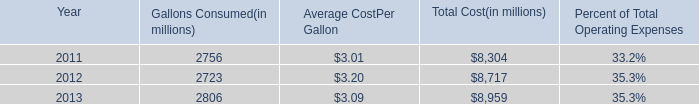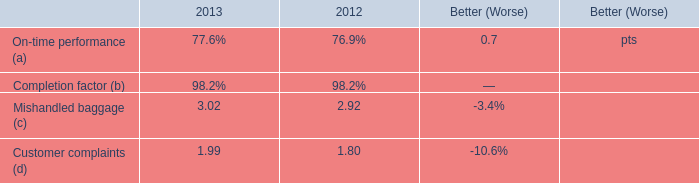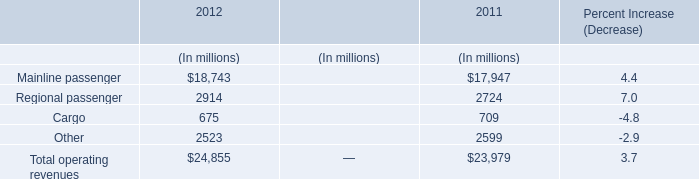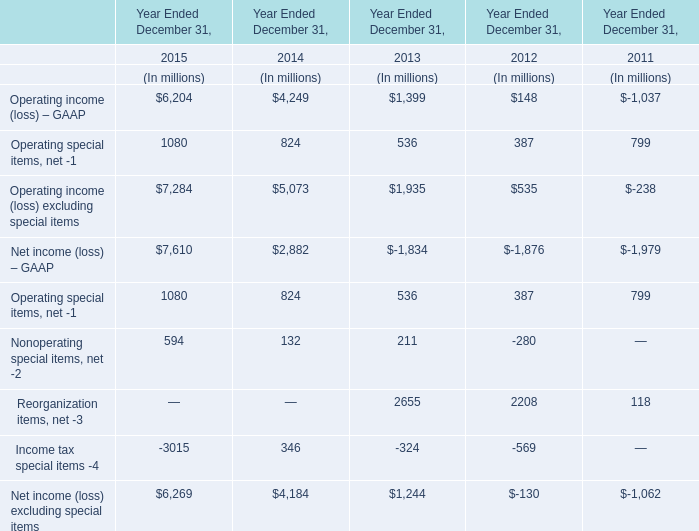What will Operating income (loss) – GAAP be like in 2016 if it continues to grow at the same rate as it did in 2015? (in million) 
Computations: (6204 + ((6204 * (6204 - 4249)) / 4249))
Answer: 9058.51165. 